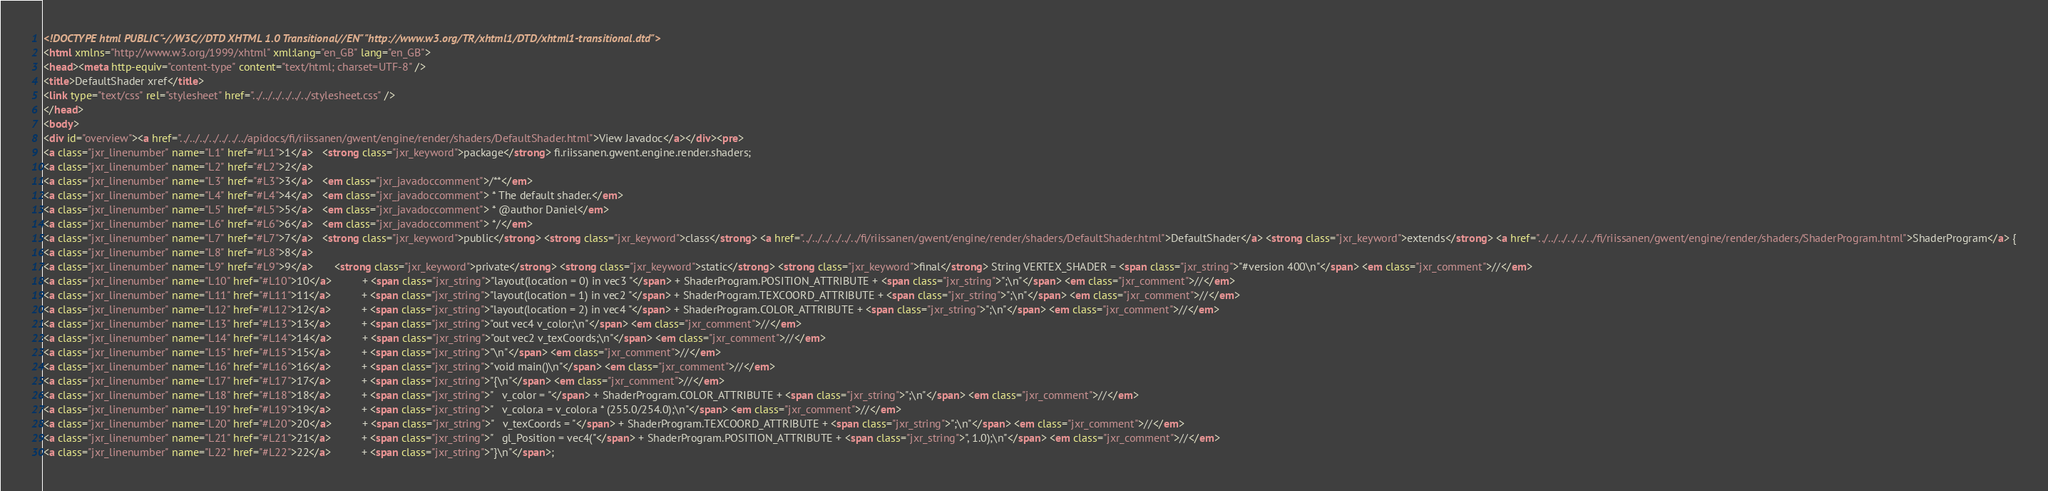Convert code to text. <code><loc_0><loc_0><loc_500><loc_500><_HTML_><!DOCTYPE html PUBLIC "-//W3C//DTD XHTML 1.0 Transitional//EN" "http://www.w3.org/TR/xhtml1/DTD/xhtml1-transitional.dtd">
<html xmlns="http://www.w3.org/1999/xhtml" xml:lang="en_GB" lang="en_GB">
<head><meta http-equiv="content-type" content="text/html; charset=UTF-8" />
<title>DefaultShader xref</title>
<link type="text/css" rel="stylesheet" href="../../../../../../stylesheet.css" />
</head>
<body>
<div id="overview"><a href="../../../../../../../apidocs/fi/riissanen/gwent/engine/render/shaders/DefaultShader.html">View Javadoc</a></div><pre>
<a class="jxr_linenumber" name="L1" href="#L1">1</a>   <strong class="jxr_keyword">package</strong> fi.riissanen.gwent.engine.render.shaders;
<a class="jxr_linenumber" name="L2" href="#L2">2</a>   
<a class="jxr_linenumber" name="L3" href="#L3">3</a>   <em class="jxr_javadoccomment">/**</em>
<a class="jxr_linenumber" name="L4" href="#L4">4</a>   <em class="jxr_javadoccomment"> * The default shader.</em>
<a class="jxr_linenumber" name="L5" href="#L5">5</a>   <em class="jxr_javadoccomment"> * @author Daniel</em>
<a class="jxr_linenumber" name="L6" href="#L6">6</a>   <em class="jxr_javadoccomment"> */</em>
<a class="jxr_linenumber" name="L7" href="#L7">7</a>   <strong class="jxr_keyword">public</strong> <strong class="jxr_keyword">class</strong> <a href="../../../../../../fi/riissanen/gwent/engine/render/shaders/DefaultShader.html">DefaultShader</a> <strong class="jxr_keyword">extends</strong> <a href="../../../../../../fi/riissanen/gwent/engine/render/shaders/ShaderProgram.html">ShaderProgram</a> {
<a class="jxr_linenumber" name="L8" href="#L8">8</a>   
<a class="jxr_linenumber" name="L9" href="#L9">9</a>       <strong class="jxr_keyword">private</strong> <strong class="jxr_keyword">static</strong> <strong class="jxr_keyword">final</strong> String VERTEX_SHADER = <span class="jxr_string">"#version 400\n"</span> <em class="jxr_comment">//</em>
<a class="jxr_linenumber" name="L10" href="#L10">10</a>          + <span class="jxr_string">"layout(location = 0) in vec3 "</span> + ShaderProgram.POSITION_ATTRIBUTE + <span class="jxr_string">";\n"</span> <em class="jxr_comment">//</em>
<a class="jxr_linenumber" name="L11" href="#L11">11</a>          + <span class="jxr_string">"layout(location = 1) in vec2 "</span> + ShaderProgram.TEXCOORD_ATTRIBUTE + <span class="jxr_string">";\n"</span> <em class="jxr_comment">//</em>
<a class="jxr_linenumber" name="L12" href="#L12">12</a>          + <span class="jxr_string">"layout(location = 2) in vec4 "</span> + ShaderProgram.COLOR_ATTRIBUTE + <span class="jxr_string">";\n"</span> <em class="jxr_comment">//</em>
<a class="jxr_linenumber" name="L13" href="#L13">13</a>          + <span class="jxr_string">"out vec4 v_color;\n"</span> <em class="jxr_comment">//</em>
<a class="jxr_linenumber" name="L14" href="#L14">14</a>          + <span class="jxr_string">"out vec2 v_texCoords;\n"</span> <em class="jxr_comment">//</em>
<a class="jxr_linenumber" name="L15" href="#L15">15</a>          + <span class="jxr_string">"\n"</span> <em class="jxr_comment">//</em>
<a class="jxr_linenumber" name="L16" href="#L16">16</a>          + <span class="jxr_string">"void main()\n"</span> <em class="jxr_comment">//</em>
<a class="jxr_linenumber" name="L17" href="#L17">17</a>          + <span class="jxr_string">"{\n"</span> <em class="jxr_comment">//</em>
<a class="jxr_linenumber" name="L18" href="#L18">18</a>          + <span class="jxr_string">"   v_color = "</span> + ShaderProgram.COLOR_ATTRIBUTE + <span class="jxr_string">";\n"</span> <em class="jxr_comment">//</em>
<a class="jxr_linenumber" name="L19" href="#L19">19</a>          + <span class="jxr_string">"   v_color.a = v_color.a * (255.0/254.0);\n"</span> <em class="jxr_comment">//</em>
<a class="jxr_linenumber" name="L20" href="#L20">20</a>          + <span class="jxr_string">"   v_texCoords = "</span> + ShaderProgram.TEXCOORD_ATTRIBUTE + <span class="jxr_string">";\n"</span> <em class="jxr_comment">//</em>
<a class="jxr_linenumber" name="L21" href="#L21">21</a>          + <span class="jxr_string">"   gl_Position = vec4("</span> + ShaderProgram.POSITION_ATTRIBUTE + <span class="jxr_string">", 1.0);\n"</span> <em class="jxr_comment">//</em>
<a class="jxr_linenumber" name="L22" href="#L22">22</a>          + <span class="jxr_string">"}\n"</span>;</code> 